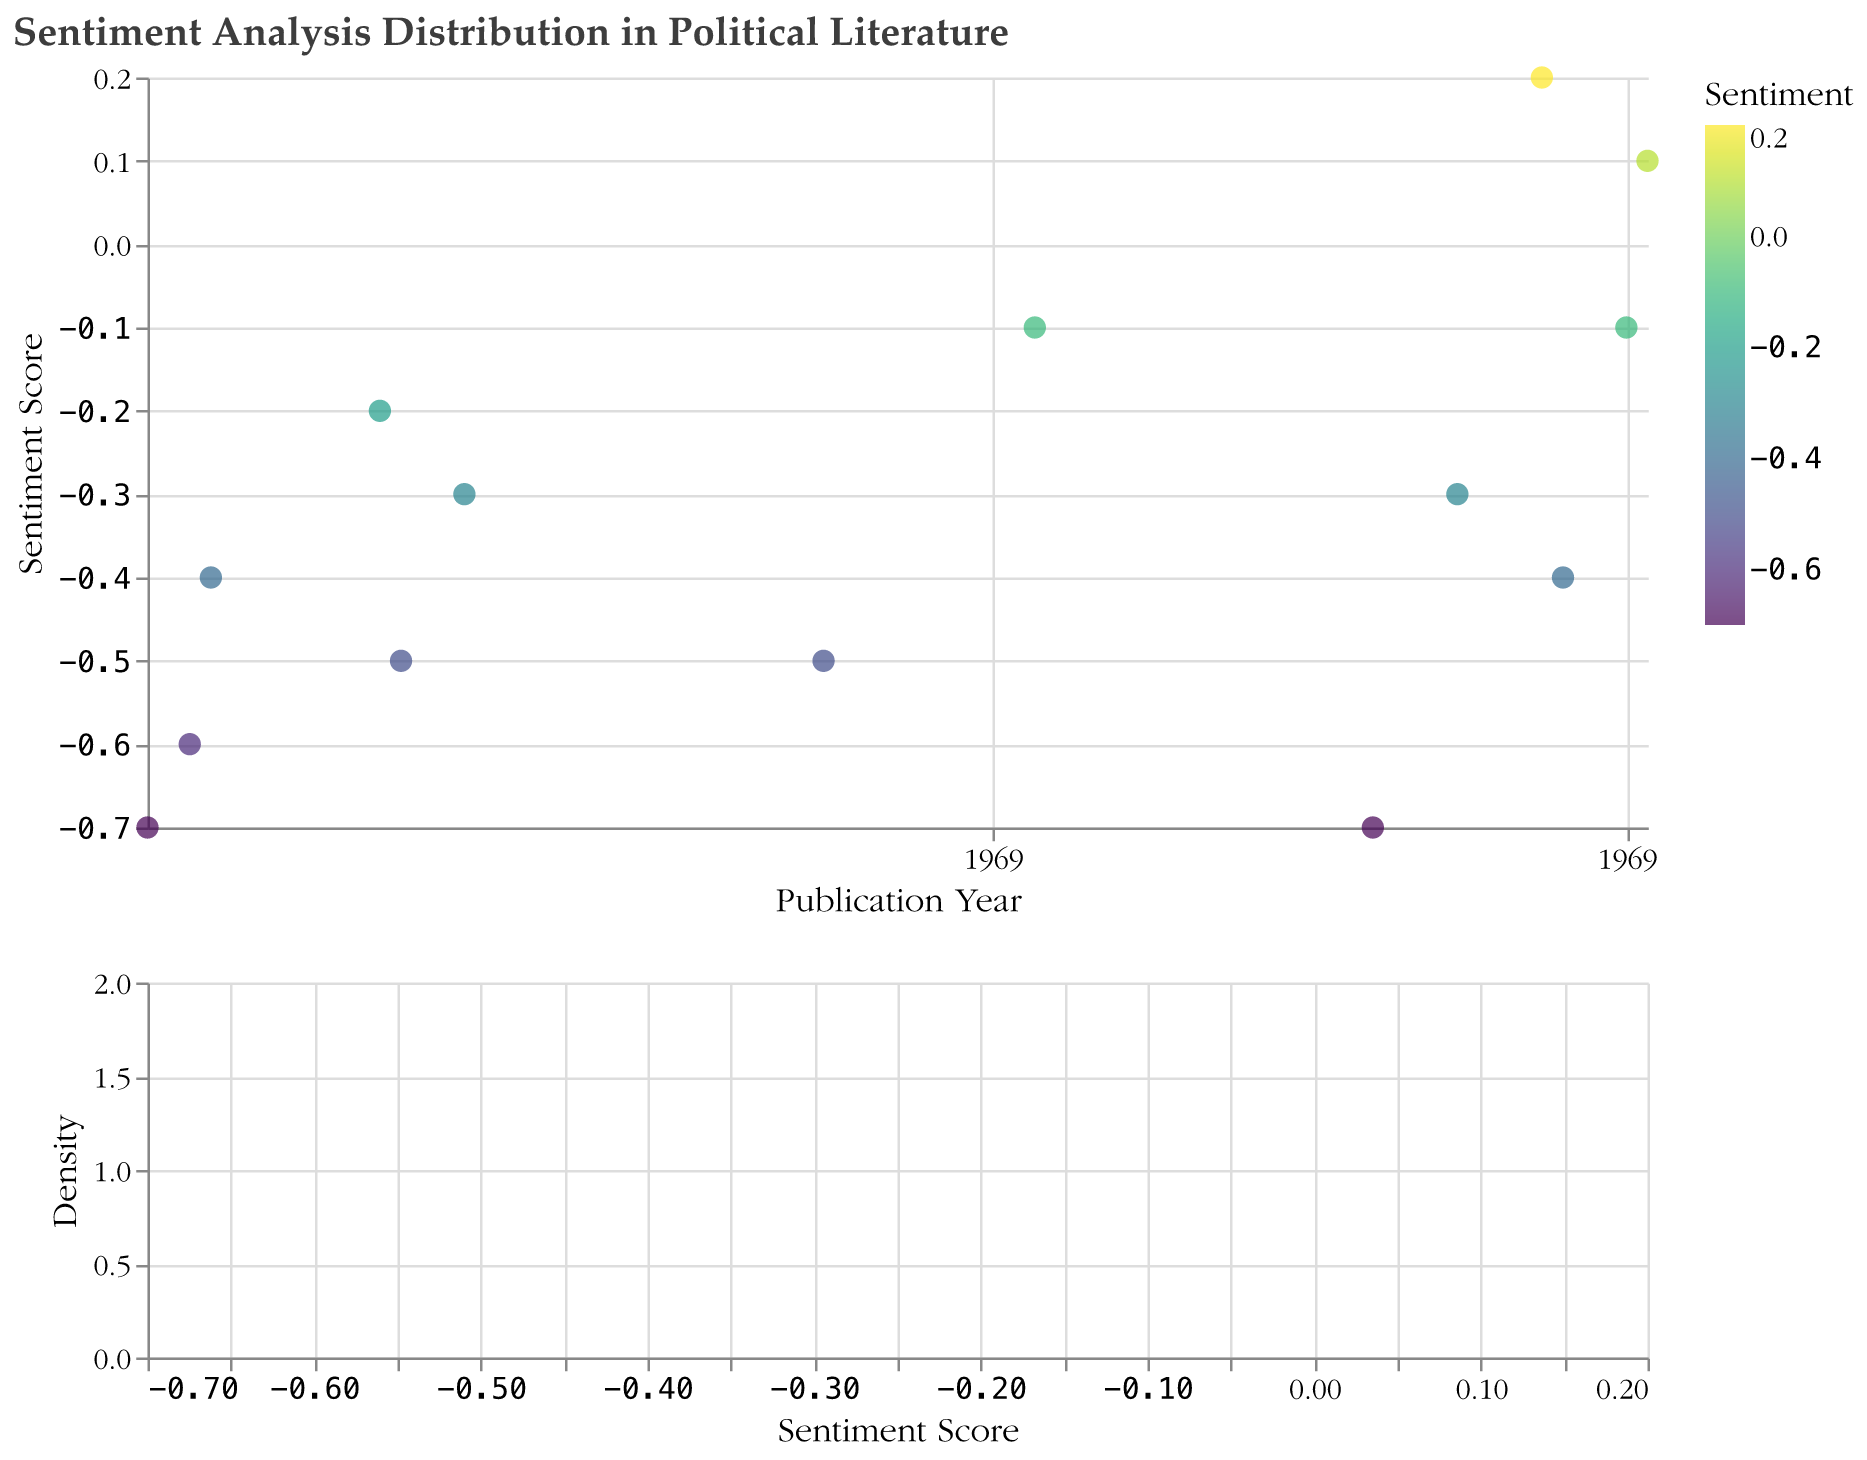What is the title of the figure? The title is displayed at the top of the figure and reads "Sentiment Analysis Distribution in Political Literature"
Answer: Sentiment Analysis Distribution in Political Literature How many data points (books) are displayed in the figure? Count the number of circles or data points representing books, each corresponding to a record in the dataset
Answer: 14 What is the range of sentiment scores shown in the plot? The sentiment scores range from the minimum to the maximum value visible on the y-axis of the scatter plot
Answer: -0.7 to 0.2 Which book has the highest sentiment score? Identify the data point with the highest position on the y-axis and check the tooltip for details
Answer: The Underground Railroad (0.2) Are there more positive or negative sentiment scores in the dataset? Compare the number of data points with positive sentiment scores (above 0) to those with negative sentiment scores (below 0)
Answer: More negative sentiment scores Which book has the lowest sentiment score and what is the score? Identify the data point with the lowest position on the y-axis and check the tooltip for details
Answer: 1984 and The Road (-0.7) How does the frequency distribution of sentiment scores look in the density plot? Observe the shape and spread of the area in the density plot; check for peaks or clusters
Answer: The density plot shows more negative sentiment scores clustered between -0.7 and -0.1, with peaks around -0.7 and -0.4 What is the mean (average) sentiment score of the books? Add the sentiment scores of all books and divide by the number of books: (-0.7 + -0.6 + -0.4 + -0.2 + -0.5 + -0.3 + -0.5 + -0.1 + -0.7 + -0.3 + 0.2 + -0.4 + -0.1 + 0.1) / 14
Answer: -0.28 What trend do you observe in the sentiment scores of political literature over time? Examine the scatter plot for any noticeable trends or patterns, such as increasing or decreasing sentiment scores over the years
Answer: Mostly negative sentiment scores with occasional positive scores in later years Which decade has the most negative average sentiment score? Calculate the average sentiment score for each decade, then compare to find the most negative
Answer: 1950s (-0.5667 from three books) Which books have a sentiment score equal to -0.4 and what years were they published? Identify the data points at y = -0.4 and check the tooltip for book titles and publication years
Answer: Fahrenheit 451 (1953) and American War (2017) 